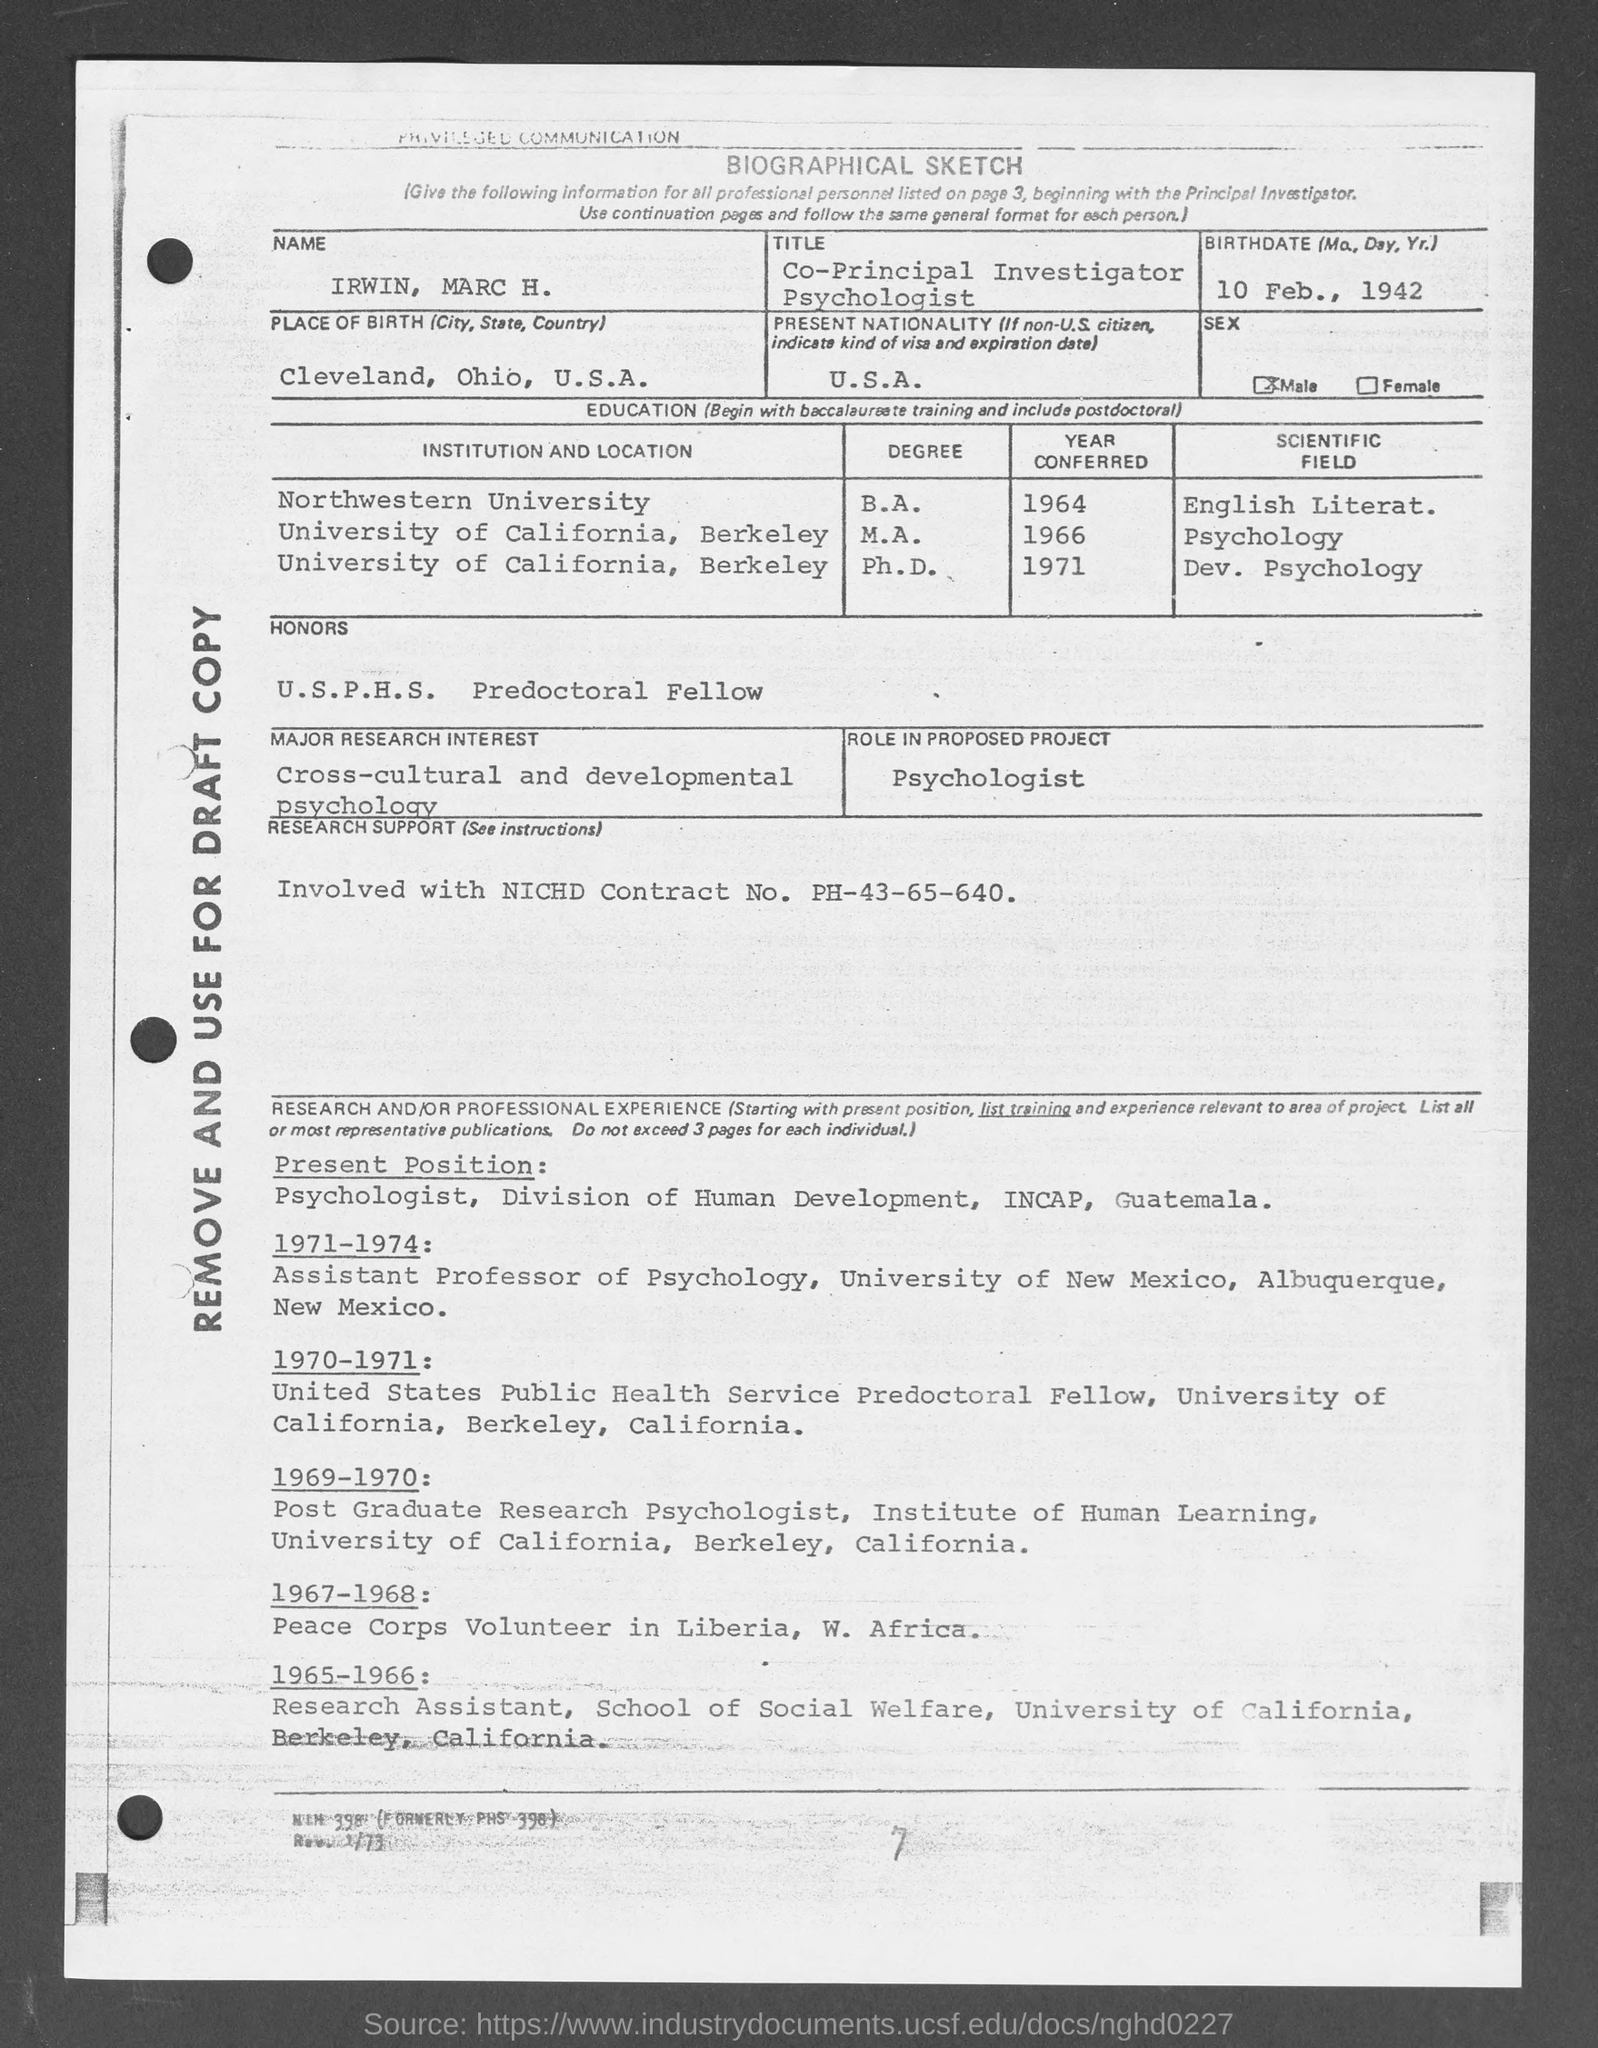Mention a couple of crucial points in this snapshot. Irwin was honored with the USPHS predoctoral fellowship. Irwin's present nationality is the United States of America. Irwin's title is Co-Principal Investigator and Psychologist. The following is a biographical sketch. Irwin was born on February 10, 1942. 